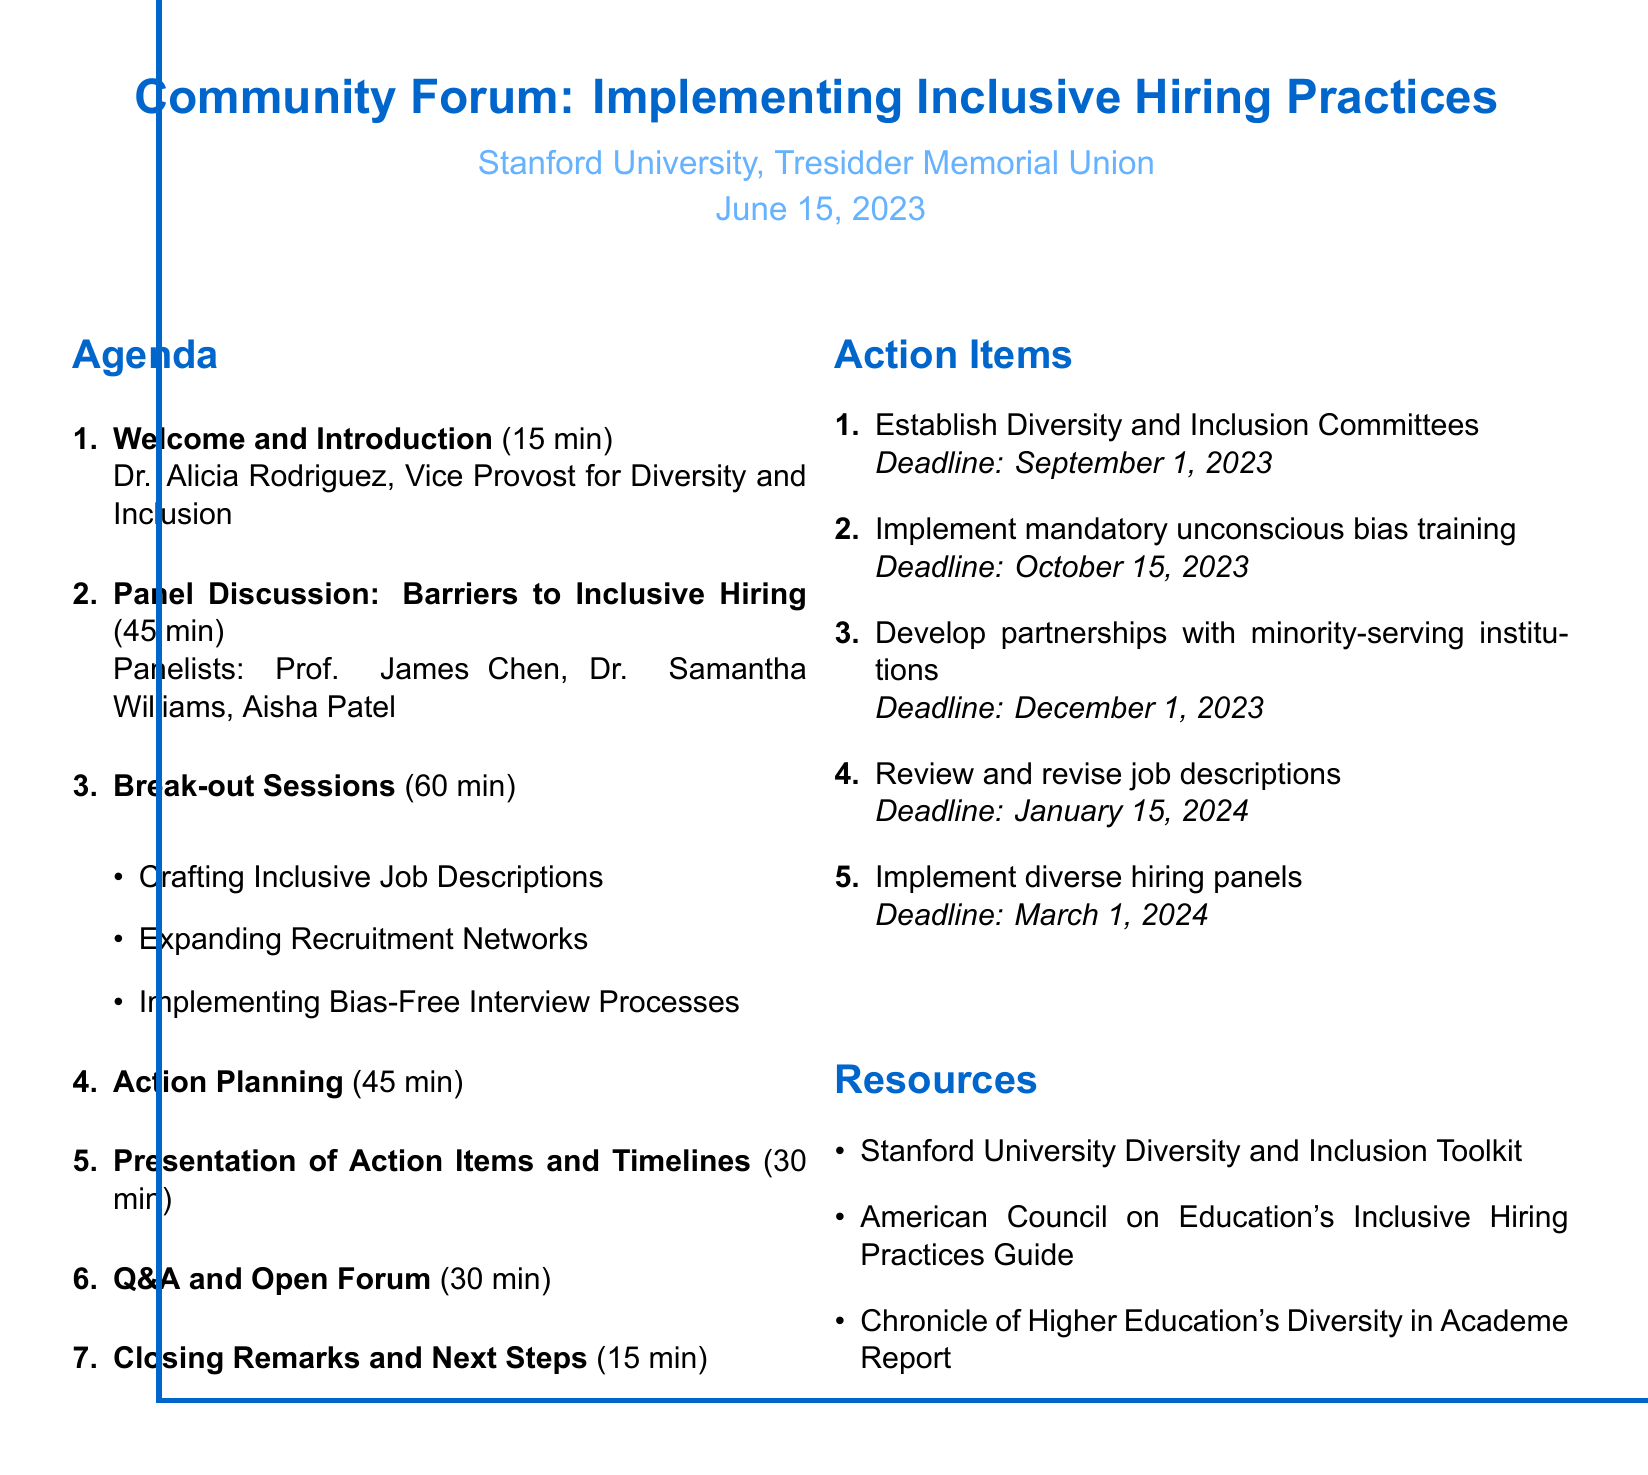What is the date of the forum? The document specifies the date of the forum as June 15, 2023.
Answer: June 15, 2023 Who is the speaker for the "Welcome and Introduction" section? The agenda indicates that Dr. Alicia Rodriguez is the speaker for this section.
Answer: Dr. Alicia Rodriguez How long is the "Panel Discussion: Barriers to Inclusive Hiring"? The duration of the panel discussion is mentioned in the agenda as 45 minutes.
Answer: 45 minutes What is one topic discussed during the panel? The document lists several topics, one of which is "Unconscious bias in recruitment."
Answer: Unconscious bias in recruitment What is the deadline for implementing mandatory unconscious bias training? The action items outline the deadline for this training as October 15, 2023.
Answer: October 15, 2023 Who is responsible for establishing Diversity and Inclusion Committees? According to the action items, Department Chairs are responsible for this task.
Answer: Department Chairs What activity is included in the "Action Planning" session? The agenda specifies that group discussions on department-specific strategies are one of the activities.
Answer: Group discussions on department-specific strategies How many break-out sessions are listed? The agenda mentions a total of three break-out sessions.
Answer: Three What is one resource mentioned in the document? The resources section of the document includes the "Stanford University Diversity and Inclusion Toolkit."
Answer: Stanford University Diversity and Inclusion Toolkit 